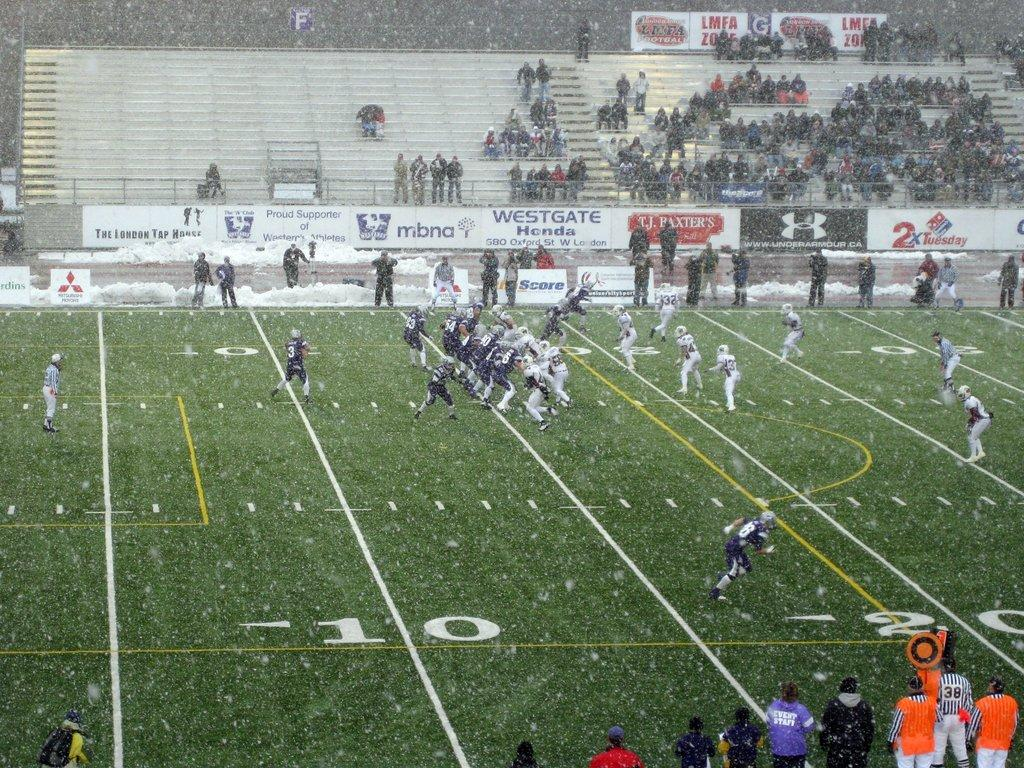What are the people in the image doing? The people in the image are sitting on stairs. What else can be seen in the image? There are players on the ground in the image. How can we differentiate between the people and players? The people and players are wearing different color dresses. What else is present in the image? There are banners visible in the image. What is the weather like in the image? Snow is falling in the image. How many times does the cannon fire in the image? There is no cannon present in the image, so it cannot fire. What type of ear is visible on the players in the image? There are no ears visible on the players in the image, as they are likely wearing helmets or headgear. 